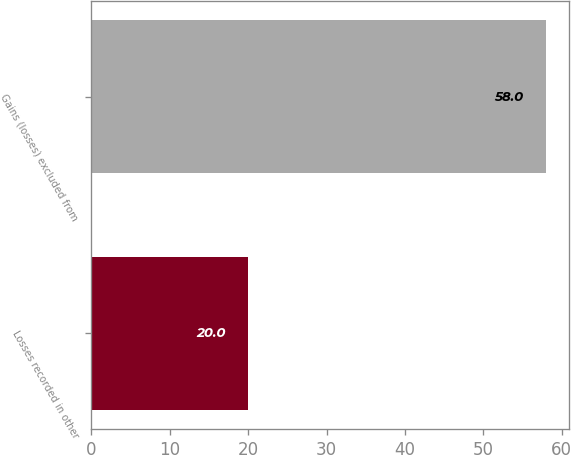Convert chart to OTSL. <chart><loc_0><loc_0><loc_500><loc_500><bar_chart><fcel>Losses recorded in other<fcel>Gains (losses) excluded from<nl><fcel>20<fcel>58<nl></chart> 